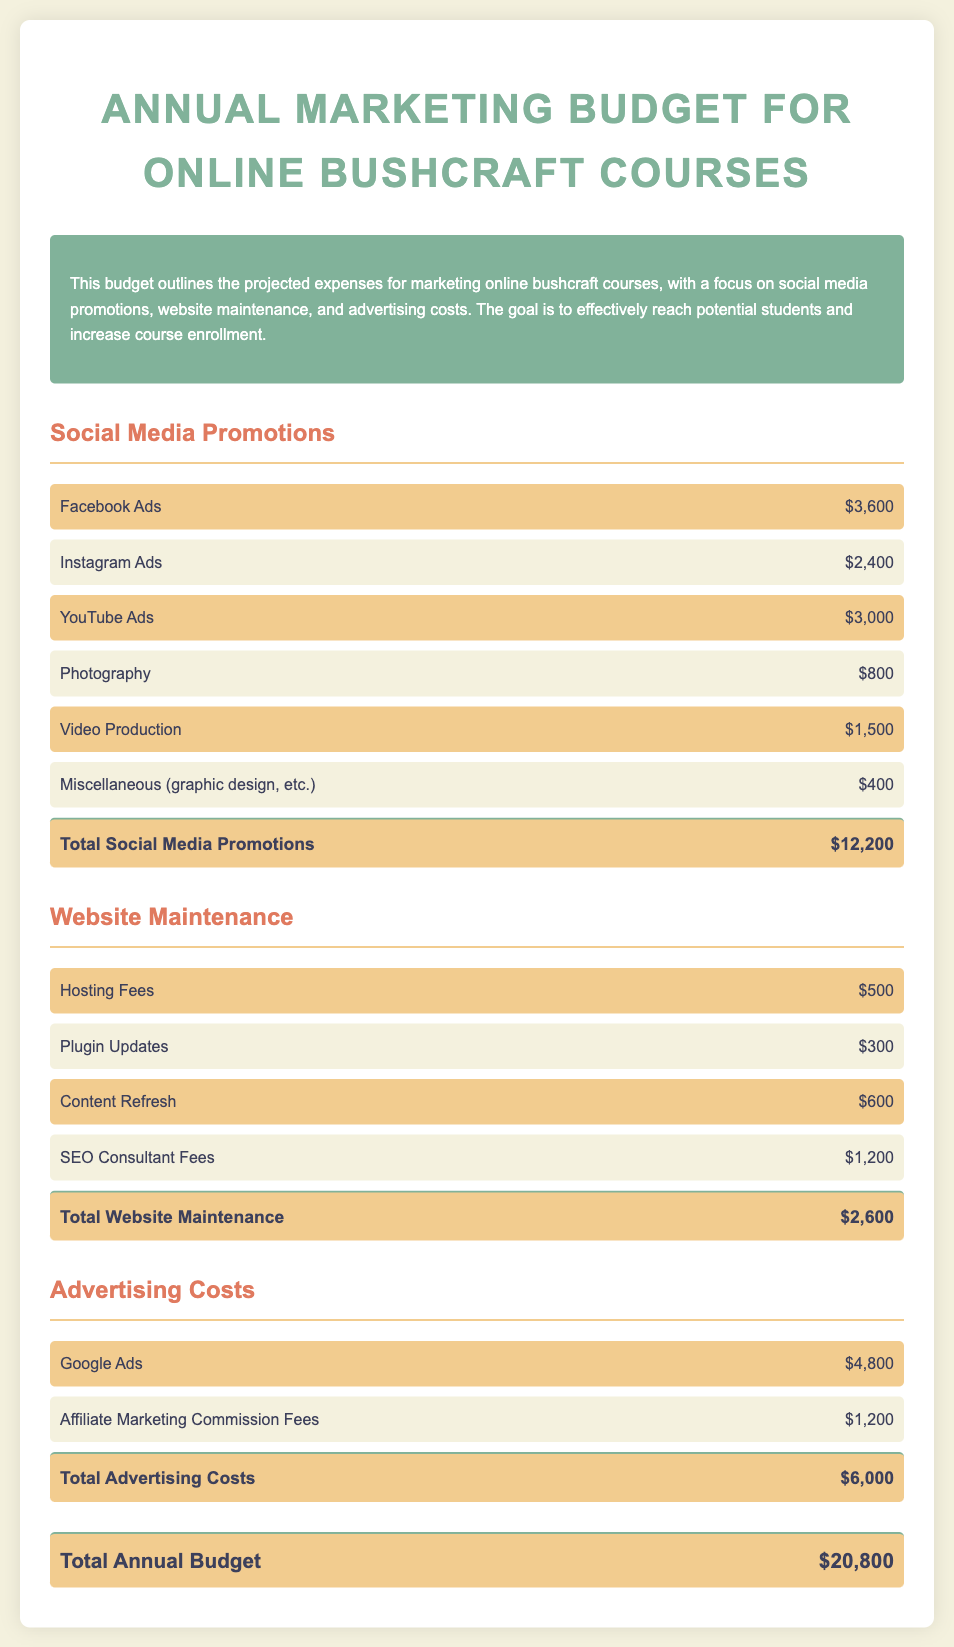What is the total budget for social media promotions? The total for social media promotions is specifically listed at the end of that section, which is $12,200.
Answer: $12,200 How much is allocated for Google Ads? The specific allocation for Google Ads is found under the Advertising Costs section, which lists it as $4,800.
Answer: $4,800 What are the total website maintenance costs? This information is provided in the website maintenance section, with a total of $2,600.
Answer: $2,600 How much is spent on video production? The budget states the amount spent on video production, which is $1,500.
Answer: $1,500 What is the overall annual marketing budget for online bushcraft courses? This is clearly stated at the end of the document as the total annual budget.
Answer: $20,800 Which social media platform has the highest ad expenditure? By comparing the amounts listed for each platform, it can be determined that Facebook Ads have the highest expenditure at $3,600.
Answer: Facebook Ads How much is budgeted for SEO consultant fees? The specific budget allocation for SEO consultant fees is $1,200 as per the website maintenance section.
Answer: $1,200 What is the budget for affiliate marketing commission fees? The document specifies the budget for affiliate marketing commission fees as $1,200 in the advertising costs section.
Answer: $1,200 How much is allocated for miscellaneous expenses in social media promotions? The budget lists miscellaneous expenses in the social media promotions section as $400.
Answer: $400 